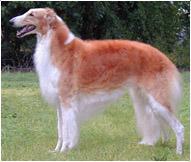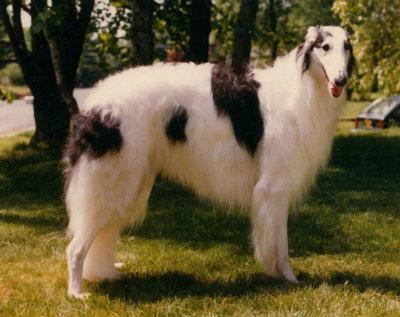The first image is the image on the left, the second image is the image on the right. Given the left and right images, does the statement "The left image shows one reddish-orange and white dog in full profile, facing left." hold true? Answer yes or no. Yes. The first image is the image on the left, the second image is the image on the right. Analyze the images presented: Is the assertion "The dog on the right is white with black spots." valid? Answer yes or no. Yes. 